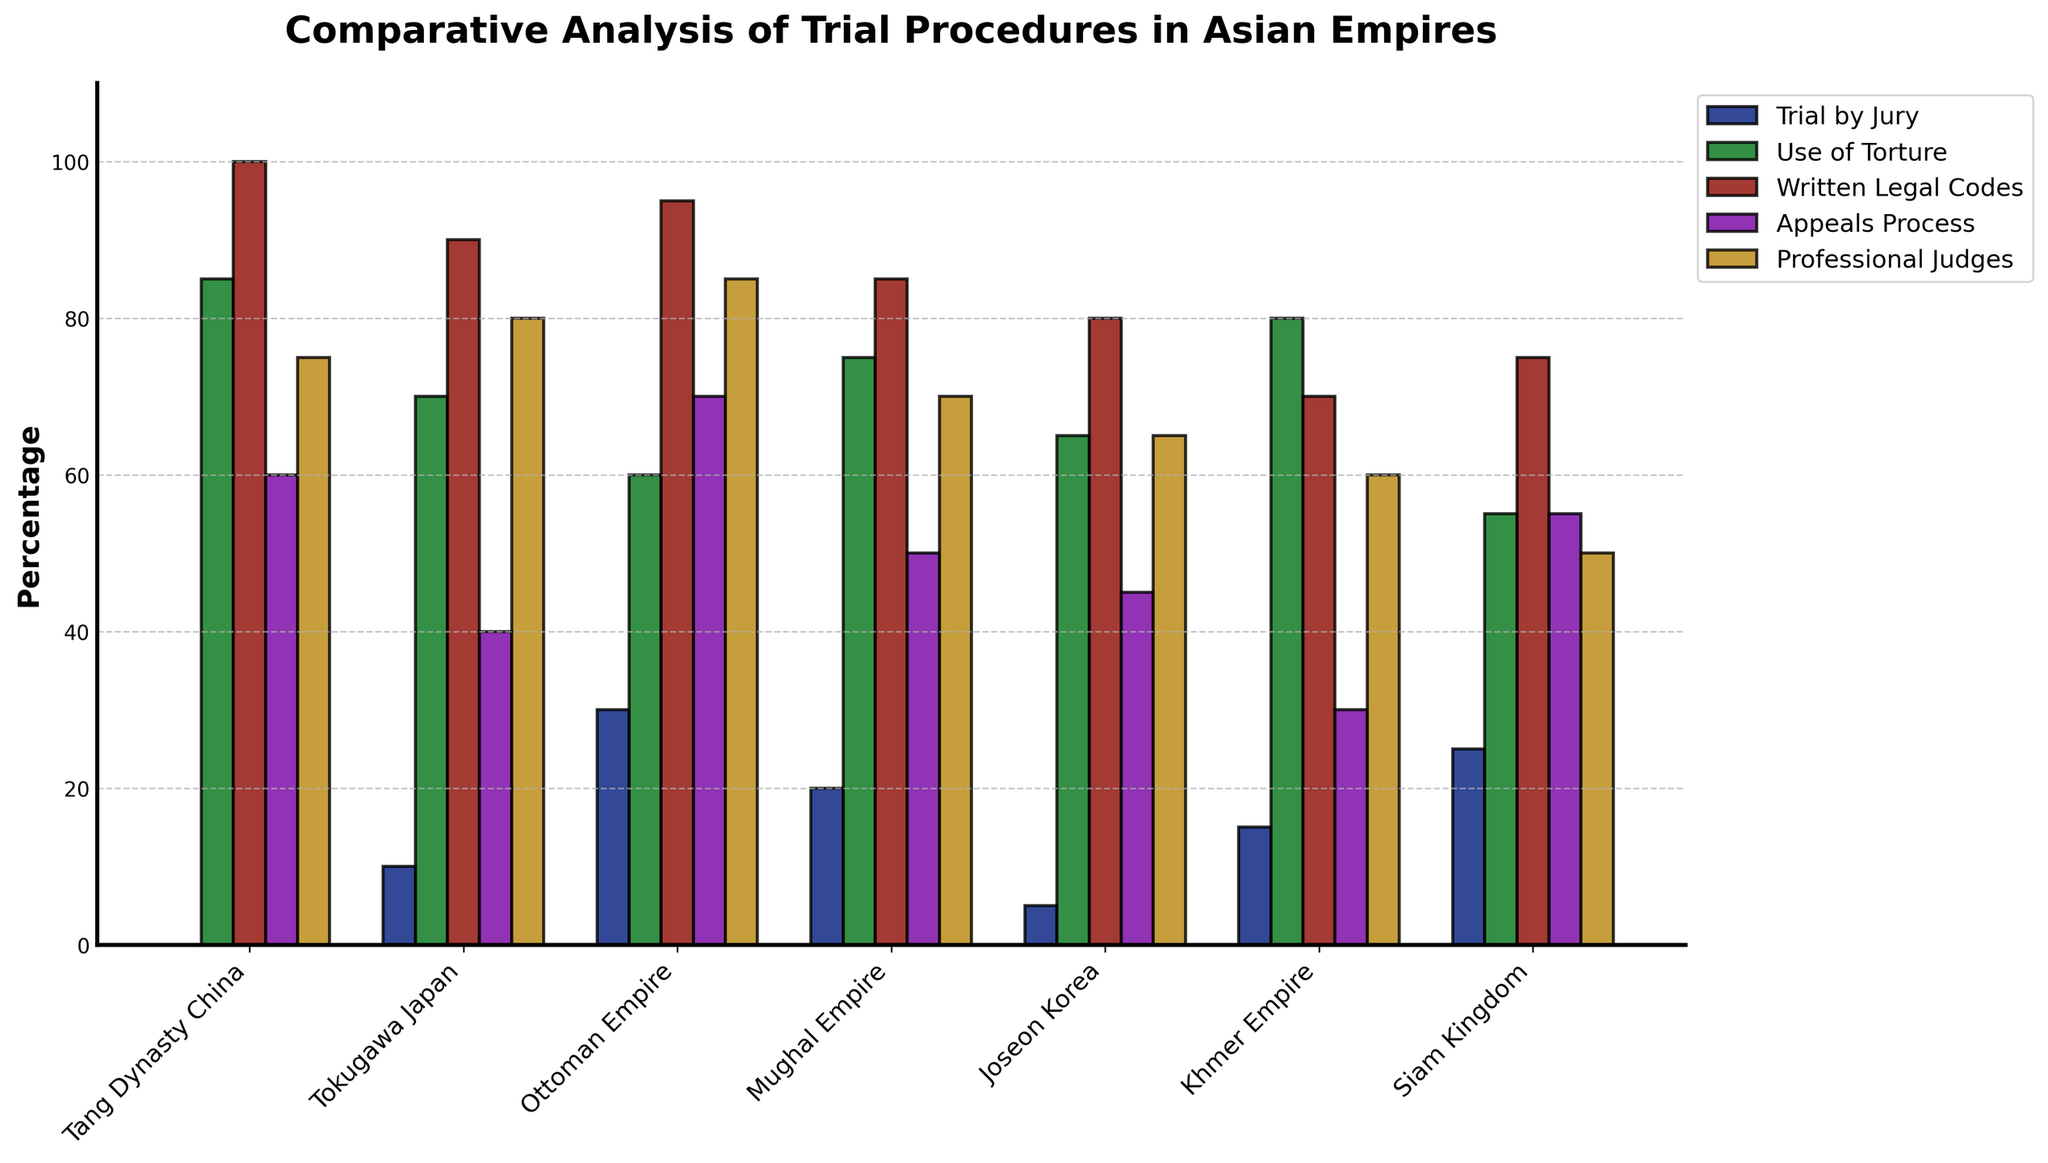Which empire uses torture the most? The empire that uses torture the most would be indicated by the tallest bar in the "Use of Torture" category. The Tang Dynasty China has a bar height of 85, which is the tallest among the empires for this category.
Answer: Tang Dynasty China Which empires allow an appeals process more than 50% of the time? The empires that are above 50% in the "Appeals Process" category will have bars taller than the 50% mark. The Tang Dynasty China (60), Ottoman Empire (70), Mughal Empire (50), and Siam Kingdom (55) all meet this criterion.
Answer: Tang Dynasty China, Ottoman Empire, Siam Kingdom What is the average percentage of "Written Legal Codes" across all empires? To find the average, add up the percentages of "Written Legal Codes" for all empires and divide by the number of empires. The values are 100, 90, 95, 85, 80, 70, and 75. The sum is 595 and the average is 595/7 = 85.
Answer: 85 How much higher is the "Professional Judges" percentage in the Ottoman Empire compared to the Joseon Korea? The "Professional Judges" percentage for the Ottoman Empire is 85 and for Joseon Korea is 65. The difference is 85 - 65 = 20.
Answer: 20 Which empire has the shortest bar for "Trial by Jury"? The shortest bar for "Trial by Jury" will be visually the smallest in height. Tang Dynasty China has a bar of 0, which is the shortest among all empires in this category.
Answer: Tang Dynasty China How many empires have more than 80% in "Use of Torture"? Number of empires with bar heights above 80 in the "Use of Torture" category. The Tang Dynasty China (85), Tokugawa Japan (70), Mughal Empire (75), Khmer Empire (80) all use torture more than 80%. This results in 4 empires.
Answer: 4 What is the combined percentage of "Trial by Jury" for the Tang Dynasty China and Siam Kingdom? To find the combined percentage, add the "Trial by Jury" values for Tang Dynasty China (0) and Siam Kingdom (25). The combined percentage is 0 + 25 = 25.
Answer: 25 Which two empires are most similar in their percentage of "Written Legal Codes"? The empires with the closest bar heights in the "Written Legal Codes" category are Mughal Empire (85) and Joseon Korea (80), which have a difference of 5.
Answer: Mughal Empire and Joseon Korea 